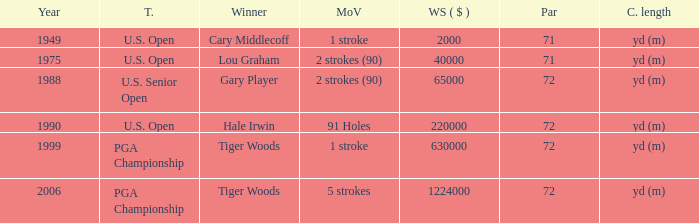When gary player is the winner what is the lowest winners share in dollars? 65000.0. 